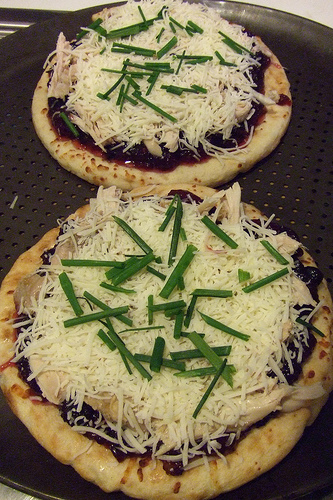<image>
Is the small pizza above the big pizza? No. The small pizza is not positioned above the big pizza. The vertical arrangement shows a different relationship. 